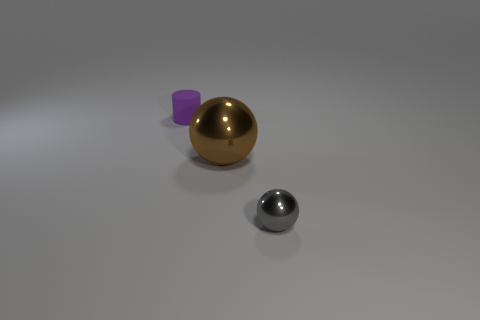Subtract all cylinders. How many objects are left? 2 Add 1 large objects. How many large objects exist? 2 Add 2 large brown metallic objects. How many objects exist? 5 Subtract all gray balls. How many balls are left? 1 Subtract 1 purple cylinders. How many objects are left? 2 Subtract all red spheres. Subtract all brown blocks. How many spheres are left? 2 Subtract all green cubes. How many gray balls are left? 1 Subtract all tiny cyan shiny objects. Subtract all spheres. How many objects are left? 1 Add 2 small purple things. How many small purple things are left? 3 